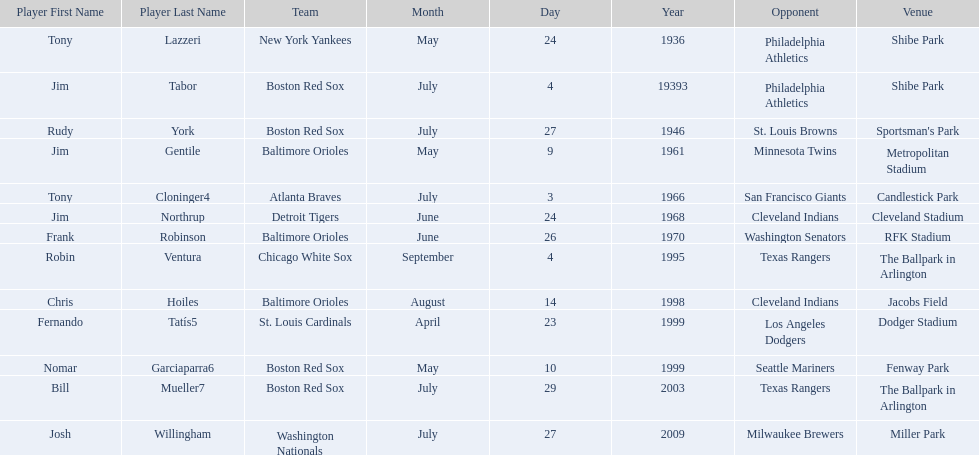What are the dates? May 24, 1936, July 4, 19393, July 27, 1946, May 9, 1961, July 3, 1966, June 24, 1968, June 26, 1970, September 4, 1995, August 14, 1998, April 23, 1999, May 10, 1999, July 29, 2003, July 27, 2009. Which date is in 1936? May 24, 1936. What player is listed for this date? Tony Lazzeri. 